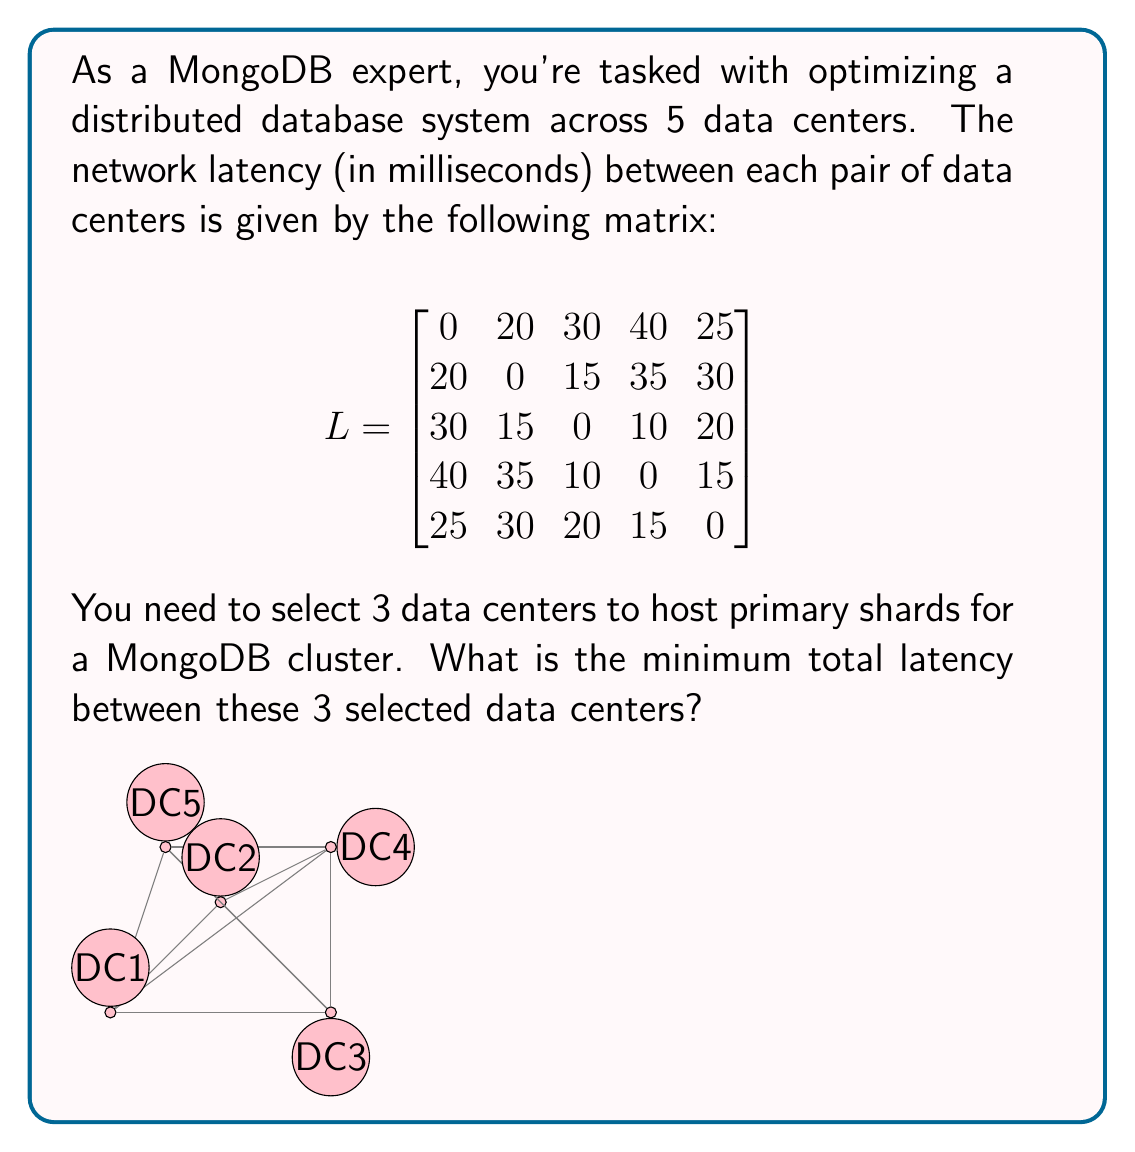Can you solve this math problem? To solve this problem, we need to find the combination of 3 data centers that minimizes the total latency between them. Here's a step-by-step approach:

1) First, we need to calculate the total latency for each possible combination of 3 data centers.

2) There are $\binom{5}{3} = 10$ possible combinations of 3 data centers out of 5.

3) For each combination, we sum the latencies between each pair of the 3 selected data centers.

4) Let's calculate for each combination:

   (1,2,3): 20 + 30 + 15 = 65
   (1,2,4): 20 + 40 + 35 = 95
   (1,2,5): 20 + 25 + 30 = 75
   (1,3,4): 30 + 40 + 10 = 80
   (1,3,5): 30 + 25 + 20 = 75
   (1,4,5): 40 + 25 + 15 = 80
   (2,3,4): 15 + 35 + 10 = 60
   (2,3,5): 15 + 30 + 20 = 65
   (2,4,5): 35 + 30 + 15 = 80
   (3,4,5): 10 + 20 + 15 = 45

5) The minimum total latency is 45, corresponding to the combination of data centers 3, 4, and 5.

This solution minimizes network latency, which is crucial for maintaining low response times and high performance in a distributed MongoDB system.
Answer: 45 ms 